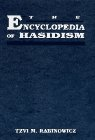Is this a games related book? No, this book is not related to games. It is strictly an academic and religious text that explores the depths of Hasidic Jewish thought and culture. 